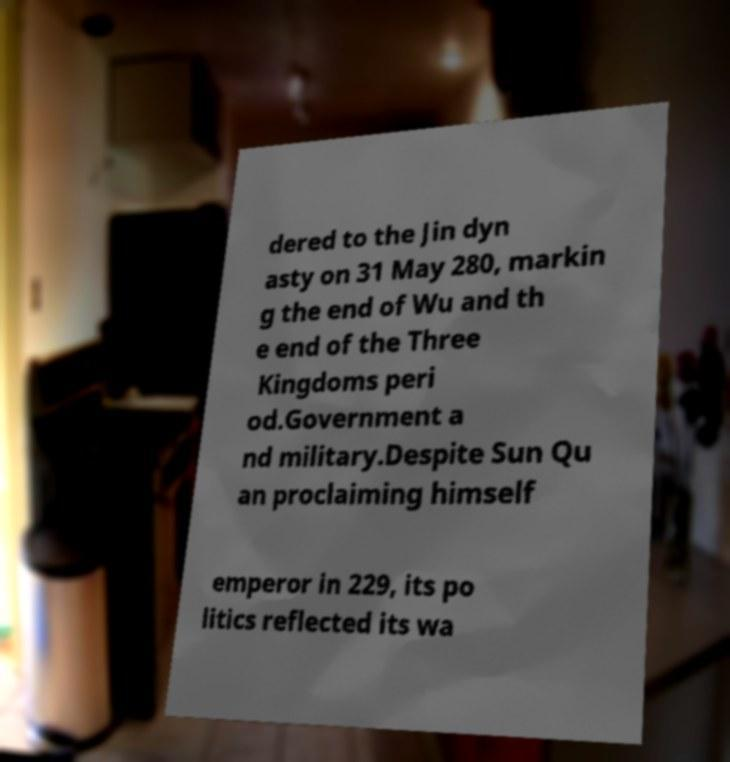There's text embedded in this image that I need extracted. Can you transcribe it verbatim? dered to the Jin dyn asty on 31 May 280, markin g the end of Wu and th e end of the Three Kingdoms peri od.Government a nd military.Despite Sun Qu an proclaiming himself emperor in 229, its po litics reflected its wa 